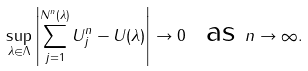<formula> <loc_0><loc_0><loc_500><loc_500>\sup _ { \lambda \in \Lambda } \left | \sum _ { j = 1 } ^ { N ^ { n } ( \lambda ) } U _ { j } ^ { n } - U ( \lambda ) \right | \to 0 \ \text { as } n \to \infty .</formula> 